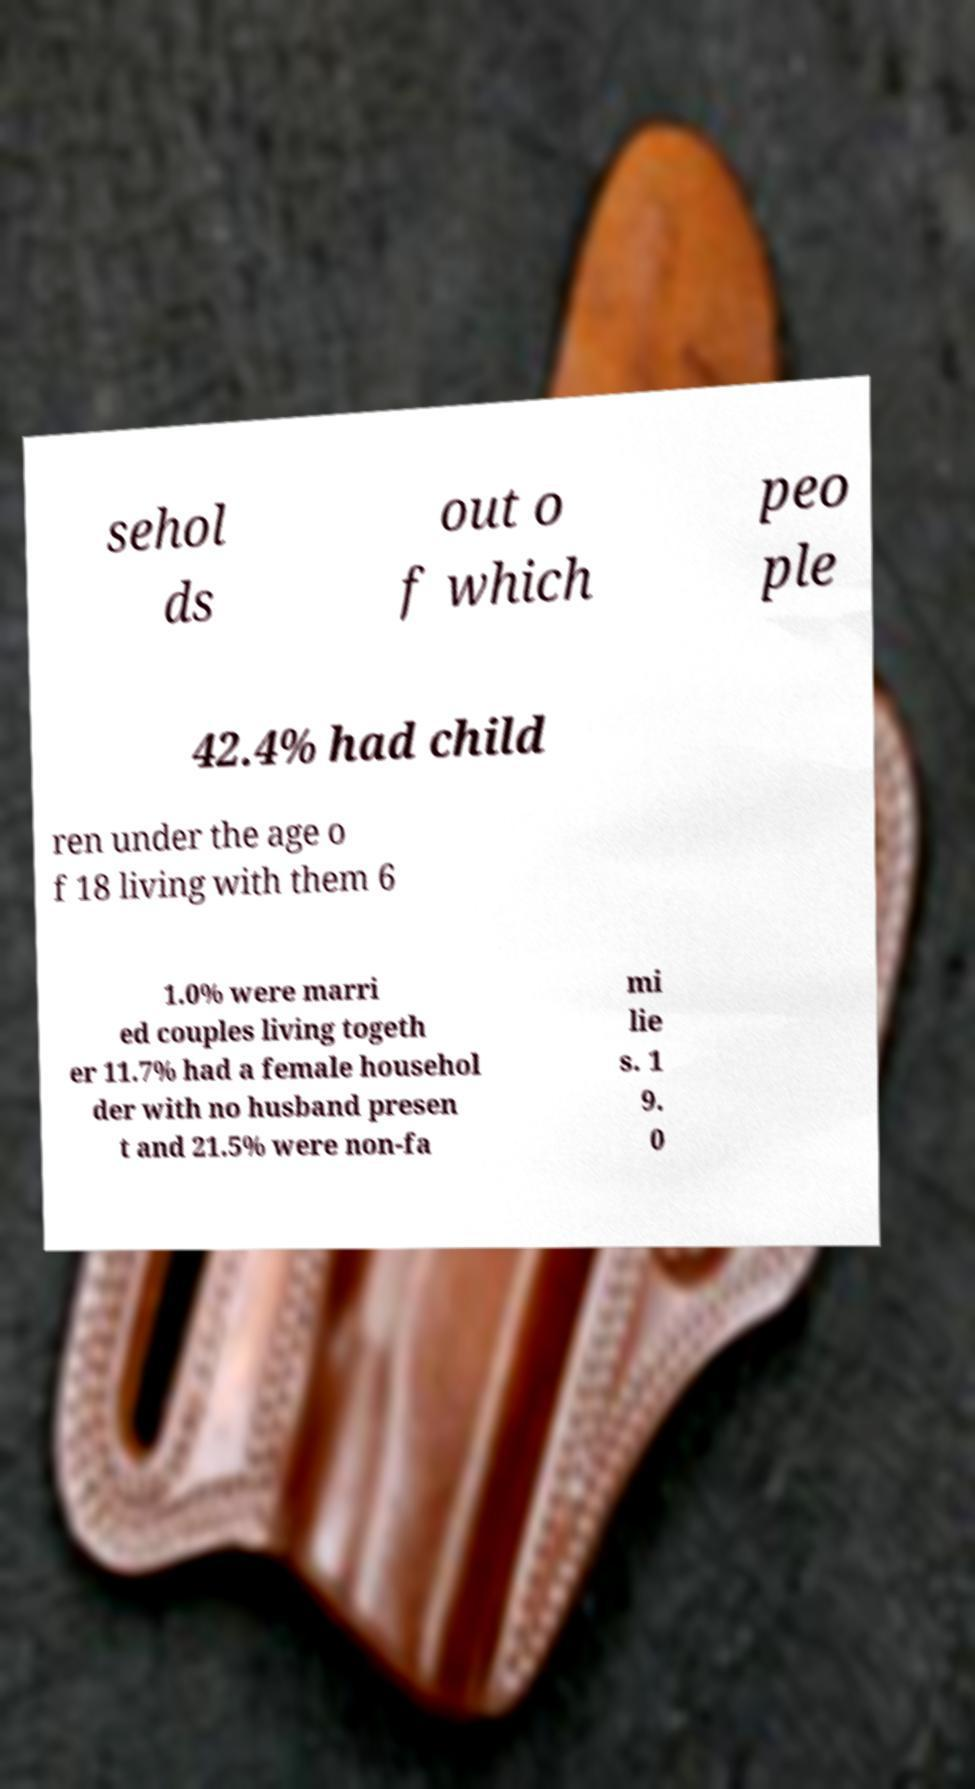Can you read and provide the text displayed in the image?This photo seems to have some interesting text. Can you extract and type it out for me? sehol ds out o f which peo ple 42.4% had child ren under the age o f 18 living with them 6 1.0% were marri ed couples living togeth er 11.7% had a female househol der with no husband presen t and 21.5% were non-fa mi lie s. 1 9. 0 